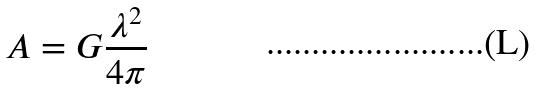<formula> <loc_0><loc_0><loc_500><loc_500>A = G \frac { \lambda ^ { 2 } } { 4 \pi }</formula> 